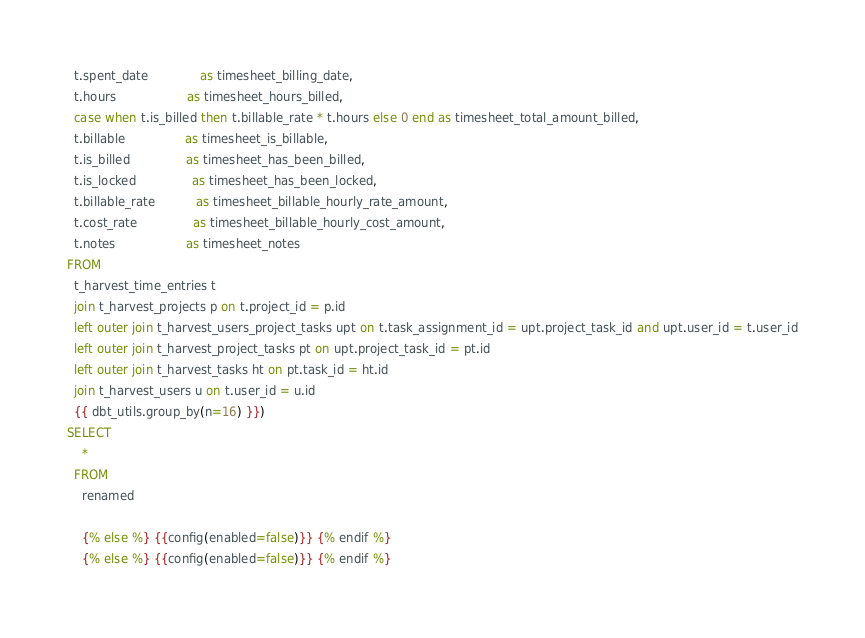<code> <loc_0><loc_0><loc_500><loc_500><_SQL_>  t.spent_date              as timesheet_billing_date,
  t.hours                   as timesheet_hours_billed,
  case when t.is_billed then t.billable_rate * t.hours else 0 end as timesheet_total_amount_billed,
  t.billable                as timesheet_is_billable,
  t.is_billed               as timesheet_has_been_billed,
  t.is_locked               as timesheet_has_been_locked,
  t.billable_rate           as timesheet_billable_hourly_rate_amount,
  t.cost_rate               as timesheet_billable_hourly_cost_amount,
  t.notes                   as timesheet_notes
FROM
  t_harvest_time_entries t
  join t_harvest_projects p on t.project_id = p.id
  left outer join t_harvest_users_project_tasks upt on t.task_assignment_id = upt.project_task_id and upt.user_id = t.user_id
  left outer join t_harvest_project_tasks pt on upt.project_task_id = pt.id
  left outer join t_harvest_tasks ht on pt.task_id = ht.id
  join t_harvest_users u on t.user_id = u.id
  {{ dbt_utils.group_by(n=16) }})
SELECT
    *
  FROM
    renamed

    {% else %} {{config(enabled=false)}} {% endif %}
    {% else %} {{config(enabled=false)}} {% endif %}
</code> 